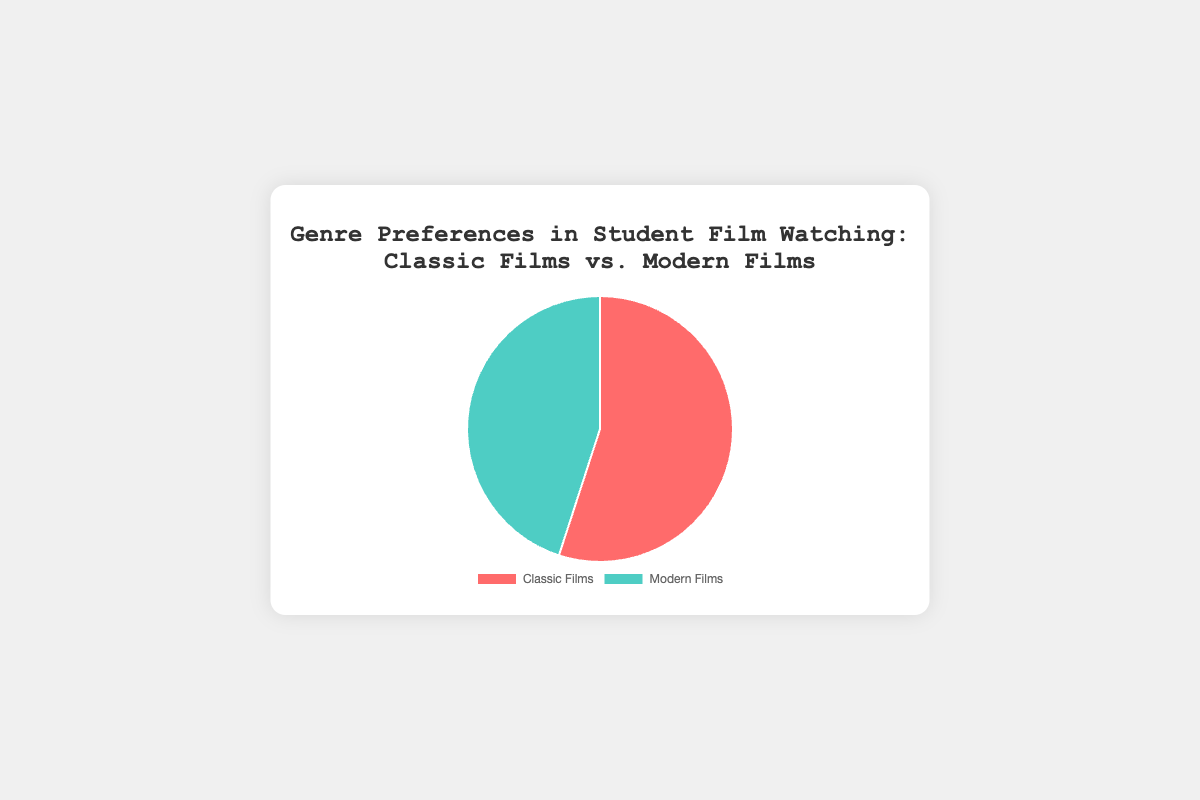What percentage of students prefer Classic Films? According to the pie chart, Classic Films occupy a segment labeled as 'Classic Films' which represents 55%.
Answer: 55% What is the difference in preference between Classic Films and Modern Films? The preferences for Classic Films is 55%, and for Modern Films is 45%. The difference is found by subtracting the smaller percentage from the larger one: 55% - 45% = 10%.
Answer: 10% Do more students prefer Modern Films or Classic Films? By looking at the pie chart, you can see that the percentage for Classic Films is 55%, which is greater than the 45% for Modern Films. So, more students prefer Classic Films.
Answer: Classic Films What fraction of the total film preferences is represented by Modern Films? Modern Films represent 45% of the preferences. As a fraction, this is 45 out of 100 or 45/100. Simplifying this fraction, we get 9/20.
Answer: 9/20 What is the total percentage of students who either prefer Classic or Modern films? The pie chart shows two categories: Classic Films (55%) and Modern Films (45%). Adding these together gives the total preference as 55% + 45% = 100%.
Answer: 100% Is the preference for Modern Films closer to 50% or to 40%? The preference for Modern Films is shown as 45%. Comparisons are made based on the proximity to 50% and 40%. Since 45 is exactly between 50 and 40 but can be closer considered from the midpoint, it’s equally distant between the two. However, visually noticeable closely to either would be equal from midpoint measure.
Answer: 45% (equally distant) If there were 200 students surveyed, how many prefer Classic Films? 55% of the students prefer Classic Films. To find how many students this represents, multiply 200 (total students) by 0.55 (the percentage in decimal form): 200 * 0.55 = 110 students.
Answer: 110 students What is represented by the red color in the pie chart? The pie chart uses red for Classic Films and another color for Modern Films. Since Classic Films are preferred by 55%, this red segment represents Classic Films and their preference that occupies this portion.
Answer: Classic Films By how much percentage is the preference for Classic Films greater than Modern Films? The pie chart shows 55% for Classic Films and 45% for Modern Films. The percentage difference is calculated by subtracting the Modern Films preference from the Classic Films preference: 55% - 45% = 10%. The preference is greater by 10%.
Answer: 10% 